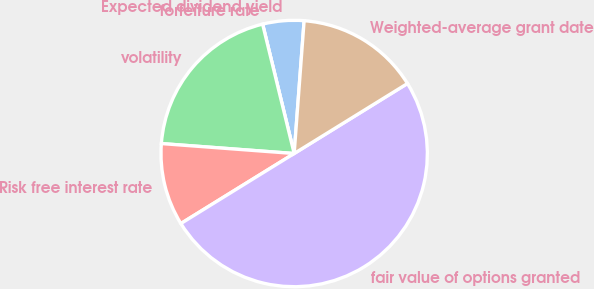<chart> <loc_0><loc_0><loc_500><loc_500><pie_chart><fcel>Expected dividend yield<fcel>forfeiture rate<fcel>volatility<fcel>Risk free interest rate<fcel>fair value of options granted<fcel>Weighted-average grant date<nl><fcel>5.0%<fcel>0.0%<fcel>20.0%<fcel>10.0%<fcel>50.0%<fcel>15.0%<nl></chart> 